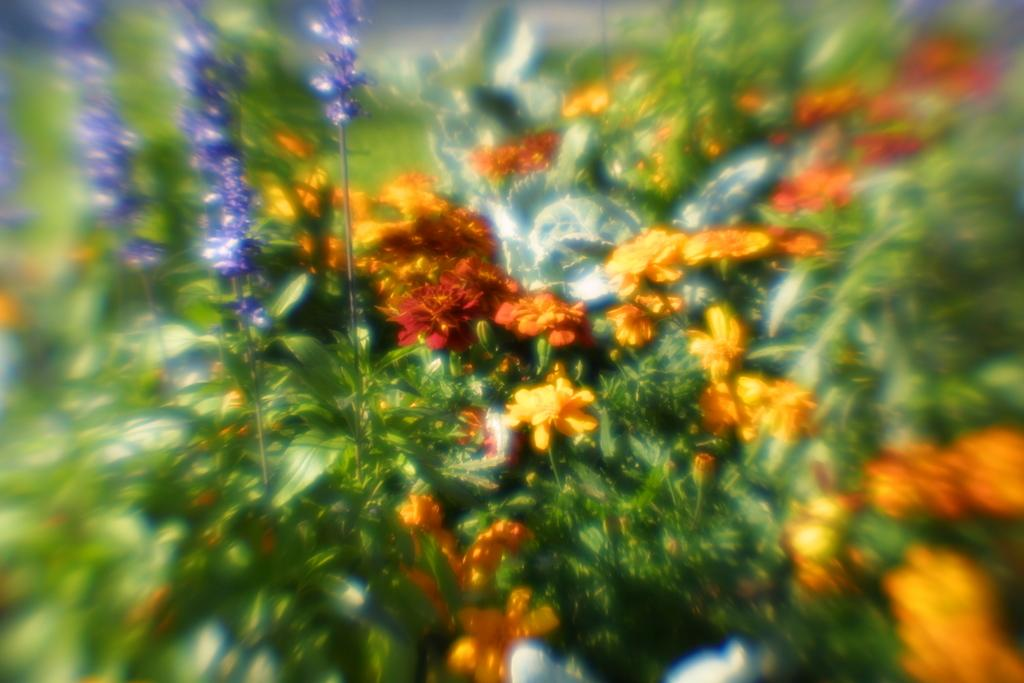What type of plant life can be seen in the image? There are leaves and flowers in the image. Can you describe the overall appearance of the image? The image is blurred. What type of pie is being served in the image? There is no pie present in the image; it only features leaves and flowers. 